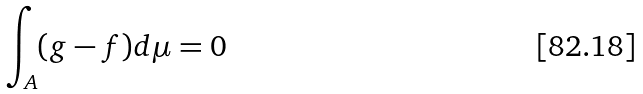<formula> <loc_0><loc_0><loc_500><loc_500>\int _ { A } ( g - f ) d \mu = 0</formula> 